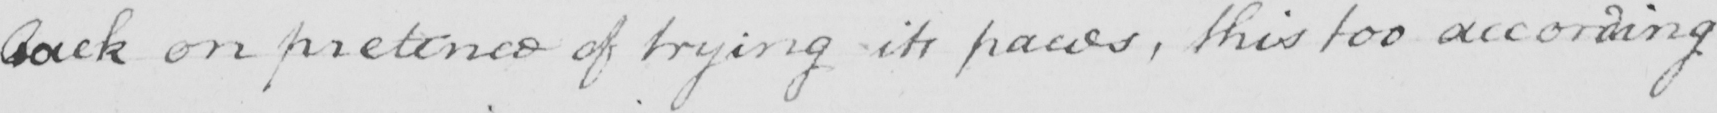Can you read and transcribe this handwriting? back on pretence of trying its paces , this too according 